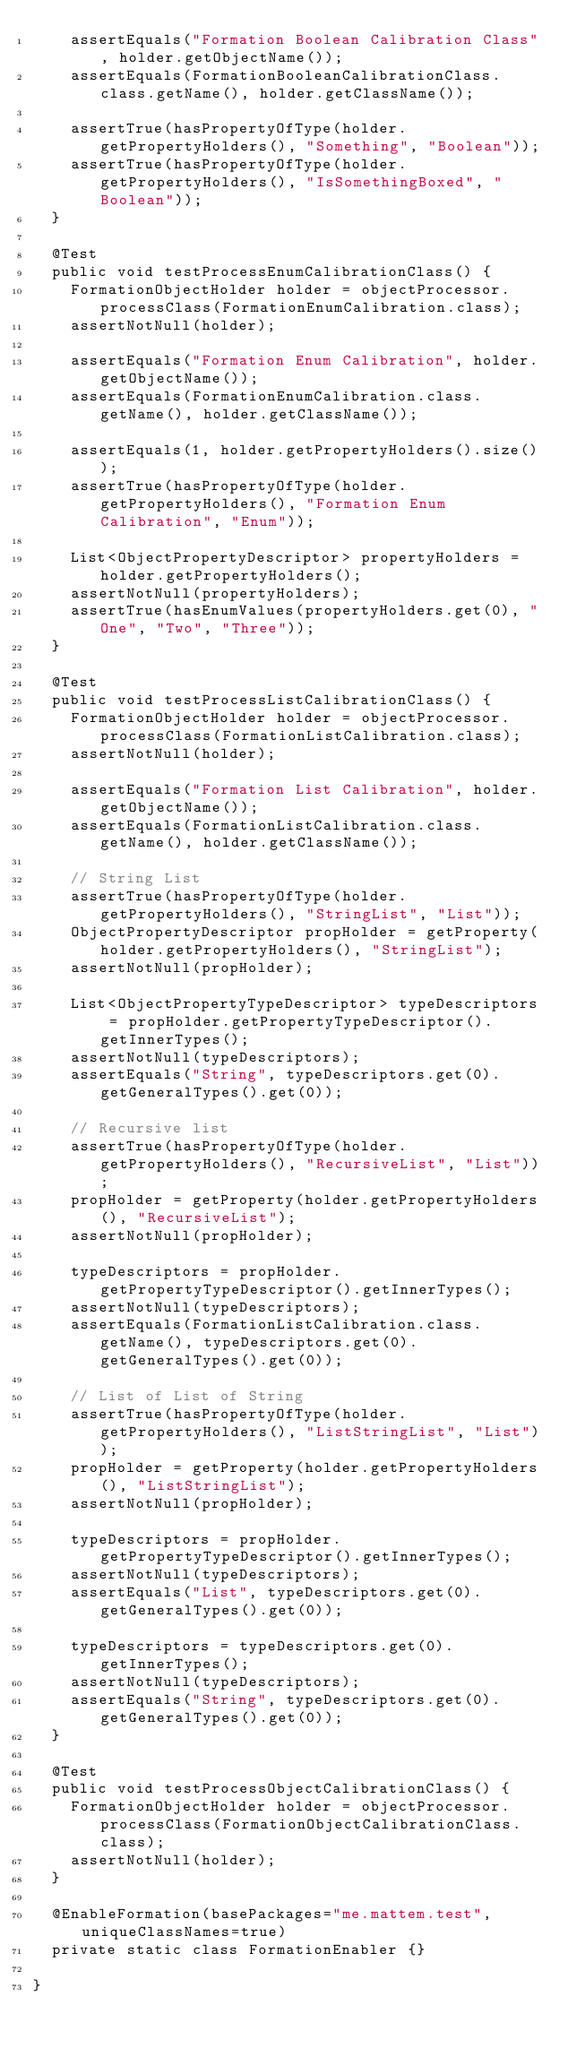<code> <loc_0><loc_0><loc_500><loc_500><_Java_>		assertEquals("Formation Boolean Calibration Class", holder.getObjectName());
		assertEquals(FormationBooleanCalibrationClass.class.getName(), holder.getClassName());
		
		assertTrue(hasPropertyOfType(holder.getPropertyHolders(), "Something", "Boolean"));
		assertTrue(hasPropertyOfType(holder.getPropertyHolders(), "IsSomethingBoxed", "Boolean"));
	}
	
	@Test
	public void testProcessEnumCalibrationClass() {
		FormationObjectHolder holder = objectProcessor.processClass(FormationEnumCalibration.class);
		assertNotNull(holder);
		
		assertEquals("Formation Enum Calibration", holder.getObjectName());
		assertEquals(FormationEnumCalibration.class.getName(), holder.getClassName());
		
		assertEquals(1, holder.getPropertyHolders().size());
		assertTrue(hasPropertyOfType(holder.getPropertyHolders(), "Formation Enum Calibration", "Enum"));
		
		List<ObjectPropertyDescriptor> propertyHolders = holder.getPropertyHolders();
		assertNotNull(propertyHolders);
		assertTrue(hasEnumValues(propertyHolders.get(0), "One", "Two", "Three"));
	}
	
	@Test
	public void testProcessListCalibrationClass() {
		FormationObjectHolder holder = objectProcessor.processClass(FormationListCalibration.class);
		assertNotNull(holder);
		
		assertEquals("Formation List Calibration", holder.getObjectName());
		assertEquals(FormationListCalibration.class.getName(), holder.getClassName());
		
		// String List
		assertTrue(hasPropertyOfType(holder.getPropertyHolders(), "StringList", "List"));
		ObjectPropertyDescriptor propHolder = getProperty(holder.getPropertyHolders(), "StringList");
		assertNotNull(propHolder);
		
		List<ObjectPropertyTypeDescriptor> typeDescriptors = propHolder.getPropertyTypeDescriptor().getInnerTypes();
		assertNotNull(typeDescriptors);
		assertEquals("String", typeDescriptors.get(0).getGeneralTypes().get(0));
		
		// Recursive list
		assertTrue(hasPropertyOfType(holder.getPropertyHolders(), "RecursiveList", "List"));
		propHolder = getProperty(holder.getPropertyHolders(), "RecursiveList");
		assertNotNull(propHolder);
		
		typeDescriptors = propHolder.getPropertyTypeDescriptor().getInnerTypes();
		assertNotNull(typeDescriptors);
		assertEquals(FormationListCalibration.class.getName(), typeDescriptors.get(0).getGeneralTypes().get(0));
		
		// List of List of String
		assertTrue(hasPropertyOfType(holder.getPropertyHolders(), "ListStringList", "List"));
		propHolder = getProperty(holder.getPropertyHolders(), "ListStringList");
		assertNotNull(propHolder);
		
		typeDescriptors = propHolder.getPropertyTypeDescriptor().getInnerTypes();
		assertNotNull(typeDescriptors);
		assertEquals("List", typeDescriptors.get(0).getGeneralTypes().get(0));
		
		typeDescriptors = typeDescriptors.get(0).getInnerTypes();
		assertNotNull(typeDescriptors);
		assertEquals("String", typeDescriptors.get(0).getGeneralTypes().get(0));
	}
	
	@Test
	public void testProcessObjectCalibrationClass() {
		FormationObjectHolder holder = objectProcessor.processClass(FormationObjectCalibrationClass.class);
		assertNotNull(holder);
	}
	
	@EnableFormation(basePackages="me.mattem.test", uniqueClassNames=true)
	private static class FormationEnabler {}

}
</code> 